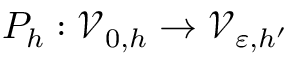Convert formula to latex. <formula><loc_0><loc_0><loc_500><loc_500>P _ { h } \colon \mathcal { V } _ { 0 , h } \to \mathcal { V } _ { \varepsilon , h ^ { \prime } }</formula> 